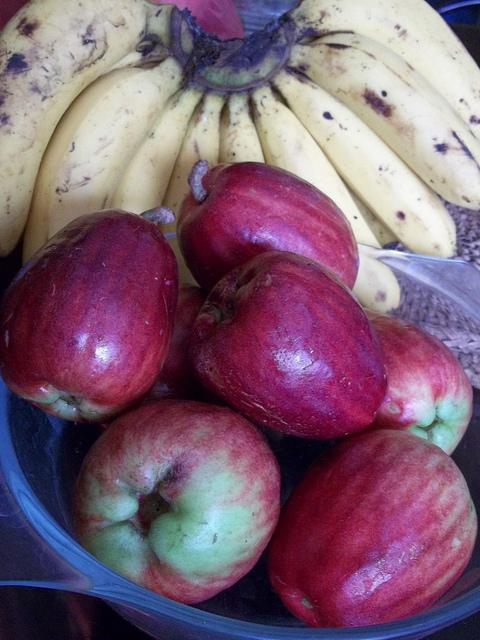Which country grows most bananas?

Choices:
A) nepal
B) india
C) us
D) china india 